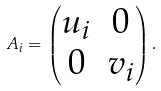Convert formula to latex. <formula><loc_0><loc_0><loc_500><loc_500>A _ { i } = \begin{pmatrix} u _ { i } & 0 \\ 0 & v _ { i } \end{pmatrix} .</formula> 